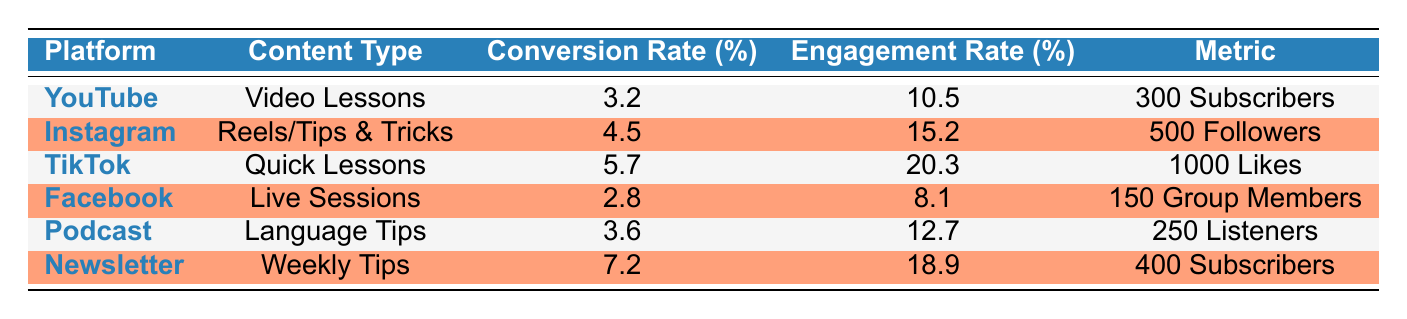What is the highest conversion rate among the platforms? The conversion rates listed in the table are 3.2, 4.5, 5.7, 2.8, 3.6, and 7.2. The highest of these values is 7.2, which corresponds to the Newsletter platform.
Answer: 7.2 Which content type on Instagram has a higher engagement rate, Reels or Stories? The table shows that Instagram has a content type of Reels/Tips & Tricks with an engagement rate of 15.2%. There is no mention of Stories on Instagram in the table; thus, no direct comparison can be made.
Answer: Not applicable Is the engagement rate for TikTok higher than that for YouTube? The engagement rate for TikTok is 20.3%, while YouTube's engagement rate is 10.5%. Since 20.3% is greater than 10.5%, the statement is true.
Answer: Yes What is the average conversion rate across all platforms? To find the average conversion rate, we sum all the conversion rates: 3.2 + 4.5 + 5.7 + 2.8 + 3.6 + 7.2 = 27.0. Then, divide by the number of platforms (6). So, 27.0 / 6 = 4.5.
Answer: 4.5 Does Facebook have a higher number of new group members than the Podcast has new listeners? Facebook has 150 new group members while the Podcast has 250 new listeners. Since 150 is less than 250, the statement is false.
Answer: No Which platform had the least engagement rate? By comparing the engagement rates: YouTube (10.5), Instagram (15.2), TikTok (20.3), Facebook (8.1), Podcast (12.7), and Newsletter (18.9), Facebook has the least at 8.1%.
Answer: Facebook Identify which content type has the highest follower growth. The content types are categorized as follows: Instagram (500 Followers), TikTok (1000 Likes), Facebook (150 Group Members), Podcast (250 Listeners), and Newsletter (400 Subscribers). The highest growth is for Instagram with 500 Followers.
Answer: Instagram What is the total number of subscribers gained across all platforms? The total subscribers can be calculated as follows: YouTube (300) + Newsletter (400) = 700. Other platforms do not specify subscribers directly in the metrics provided (TikTok uses Likes, etc.). Thus, 700 is the total for the contexts provided.
Answer: 700 